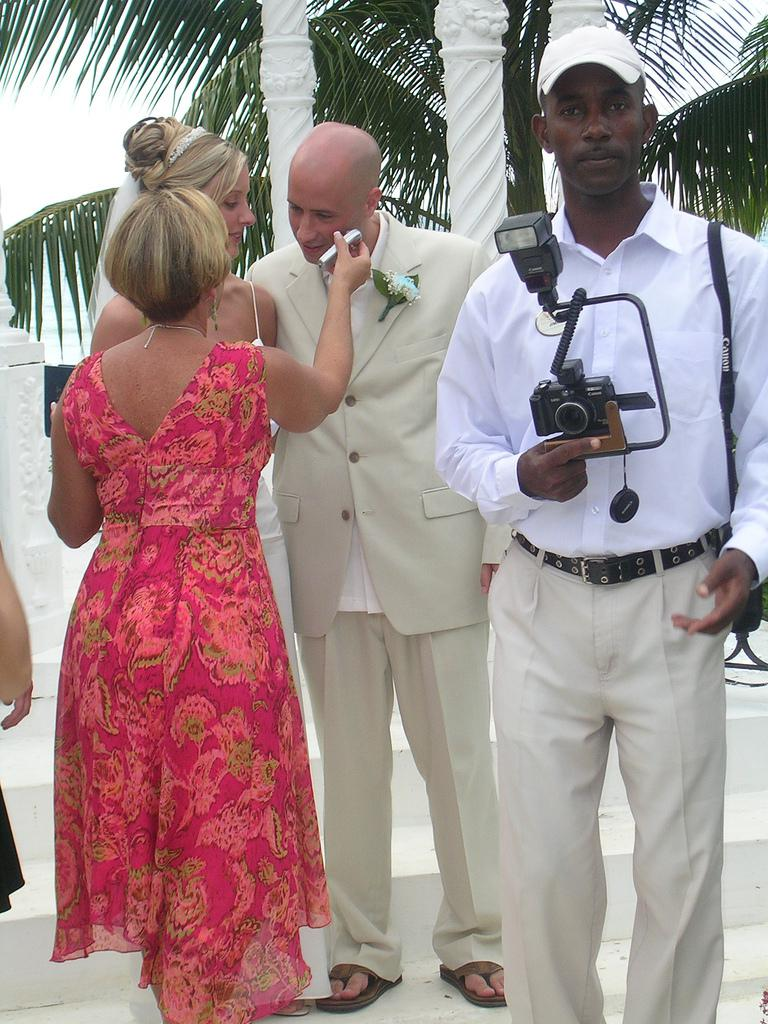Question: how many people are in this photo?
Choices:
A. Six.
B. Two.
C. Eight.
D. Four.
Answer with the letter. Answer: D Question: who are the two in the back?
Choices:
A. Sister and brother.
B. Husband and wife.
C. Father and son.
D. Mother and daughter.
Answer with the letter. Answer: B Question: what foot wear is the man in the middle wearing?
Choices:
A. Sneakers.
B. Hiking boots.
C. Sandals.
D. Loafers.
Answer with the letter. Answer: C Question: what color is the brides dress?
Choices:
A. Mauve.
B. White.
C. Off white.
D. Lavender.
Answer with the letter. Answer: B Question: what is the lady in red doing?
Choices:
A. Cooking.
B. Holding up the phone for the man.
C. Eating.
D. Walking.
Answer with the letter. Answer: B Question: who is wearing a pink dress?
Choices:
A. A girl.
B. A dog.
C. A man.
D. A woman.
Answer with the letter. Answer: D Question: who is the man in the white ball cap?
Choices:
A. Photographer.
B. A Father.
C. The Coach.
D. The other man's brother.
Answer with the letter. Answer: A Question: who will be getting their photos taken?
Choices:
A. The parents.
B. The bridesmaids.
C. The bride and groom.
D. The groomsmen.
Answer with the letter. Answer: C Question: where is the lens cap?
Choices:
A. On the table.
B. On the ground.
C. Hanging from the camera.
D. Off of the camera.
Answer with the letter. Answer: D Question: what has designs carved into them?
Choices:
A. The fenceposts.
B. The columns.
C. The pillars.
D. The concrete walls.
Answer with the letter. Answer: C Question: what color is the grooms suit?
Choices:
A. Black.
B. Blue.
C. Pink.
D. Beige.
Answer with the letter. Answer: D Question: what is the groom wearing on his feet?
Choices:
A. Black shoes.
B. Cowboy boots.
C. Flip flops.
D. Slippers.
Answer with the letter. Answer: C Question: what is white?
Choices:
A. Shoes.
B. Socks.
C. Dress.
D. Pearls.
Answer with the letter. Answer: C Question: who is bald?
Choices:
A. Baby.
B. Old dog.
C. Eagle.
D. Man.
Answer with the letter. Answer: D Question: who is standing on a step?
Choices:
A. Flowergirl.
B. Bridesmaids.
C. Bride and groom.
D. Groom's men.
Answer with the letter. Answer: C Question: who is holding a camera?
Choices:
A. The black man.
B. The woman.
C. The professional photogropher.
D. An asian adolescent.
Answer with the letter. Answer: A Question: how many ladies have blonde hair?
Choices:
A. Three.
B. Four.
C. Five.
D. Two.
Answer with the letter. Answer: D Question: who is wearing a pink floral dress?
Choices:
A. The girl.
B. The lady.
C. The teen.
D. The children.
Answer with the letter. Answer: B 